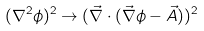<formula> <loc_0><loc_0><loc_500><loc_500>( \nabla ^ { 2 } \phi ) ^ { 2 } \to ( \vec { \nabla } \cdot ( \vec { \nabla } \phi - \vec { A } ) ) ^ { 2 }</formula> 